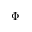<formula> <loc_0><loc_0><loc_500><loc_500>\Phi</formula> 